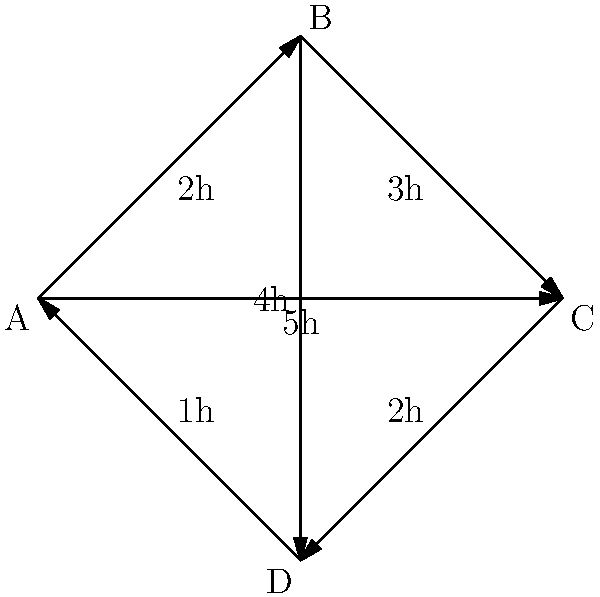As a Vueling Airlines representative, you're tasked with optimizing flight routes between four cities (A, B, C, and D) represented in the network diagram. The numbers on each edge represent flight durations in hours. What is the minimum total flight time required to visit all four cities exactly once, starting and ending at city A? To solve this problem, we need to find the shortest Hamiltonian cycle in the given network. Here's a step-by-step approach:

1) List all possible routes starting and ending at A, visiting each city once:
   - A → B → C → D → A
   - A → B → D → C → A
   - A → C → B → D → A
   - A → C → D → B → A
   - A → D → B → C → A
   - A → D → C → B → A

2) Calculate the total time for each route:
   - A → B → C → D → A: 2 + 3 + 2 + 1 = 8 hours
   - A → B → D → C → A: 2 + 4 + 2 + 5 = 13 hours
   - A → C → B → D → A: 5 + 3 + 4 + 1 = 13 hours
   - A → C → D → B → A: 5 + 2 + 4 + 2 = 13 hours
   - A → D → B → C → A: 1 + 4 + 3 + 5 = 13 hours
   - A → D → C → B → A: 1 + 2 + 3 + 2 = 8 hours

3) Identify the route(s) with the minimum total time:
   Two routes have the minimum time of 8 hours:
   - A → B → C → D → A
   - A → D → C → B → A

Therefore, the minimum total flight time required to visit all four cities exactly once, starting and ending at city A, is 8 hours.
Answer: 8 hours 